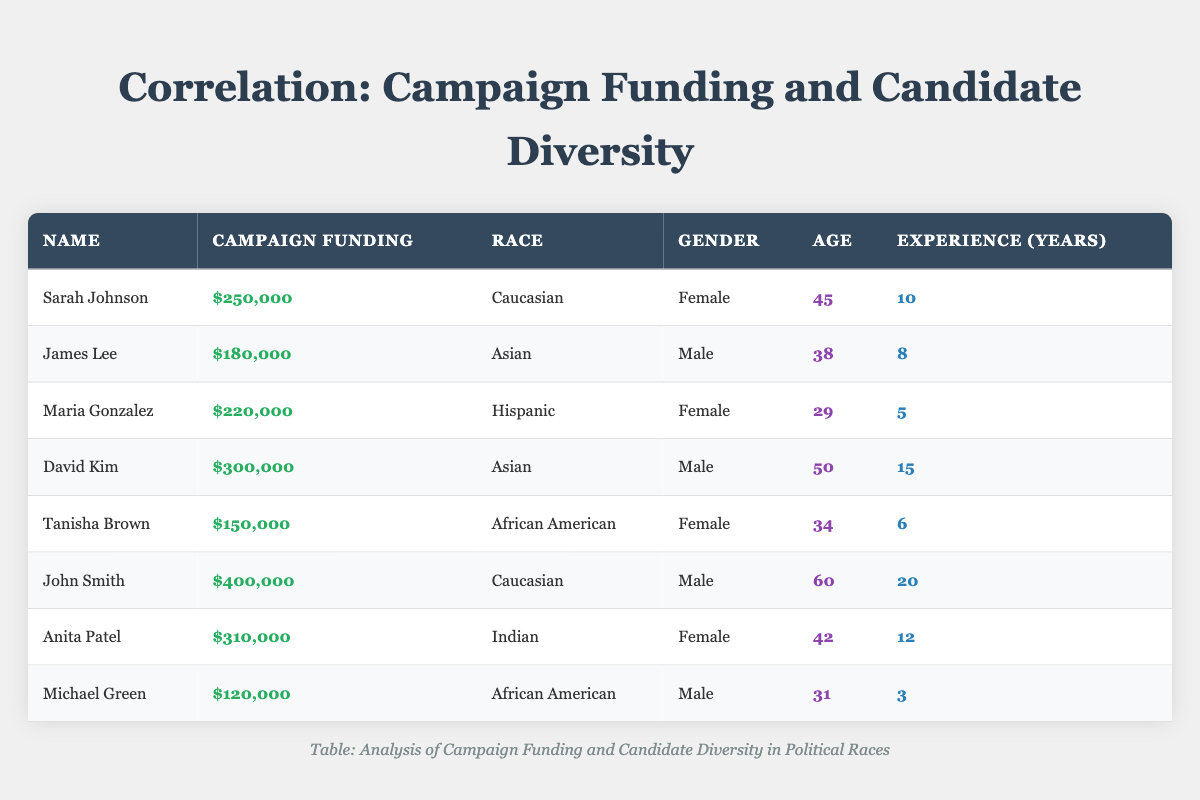What is the total campaign funding for candidates from the African American demographic? The two candidates from the African American demographic are Tanisha Brown, who has campaign funding of $150,000, and Michael Green, who has funding of $120,000. Adding these two amounts yields $150,000 + $120,000 = $270,000.
Answer: $270,000 What is the age of the candidate with the highest campaign funding? The candidate with the highest campaign funding is John Smith, who has $400,000. Referring to the table, his age is noted as 60.
Answer: 60 Is there a female candidate with more than $300,000 in campaign funding? Checking the table, only Anita Patel and Sarah Johnson are female candidates. Anita has $310,000, which exceeds $300,000. Thus, the statement is true.
Answer: Yes What is the average campaign funding for candidates aged 40 and above? Candidates aged 40 and above are Sarah Johnson (45), David Kim (50), John Smith (60), and Anita Patel (42). Their campaign funding amounts are $250,000, $300,000, $400,000, and $310,000. Summing these gives $250,000 + $300,000 + $400,000 + $310,000 = $1,260,000. Dividing by the number of candidates (4) results in an average of $1,260,000 / 4 = $315,000.
Answer: $315,000 How many candidates have more than 10 years of experience? The candidates with more than 10 years of experience are David Kim with 15 years, John Smith with 20 years, and Anita Patel with 12 years. Therefore, there are 3 candidates.
Answer: 3 